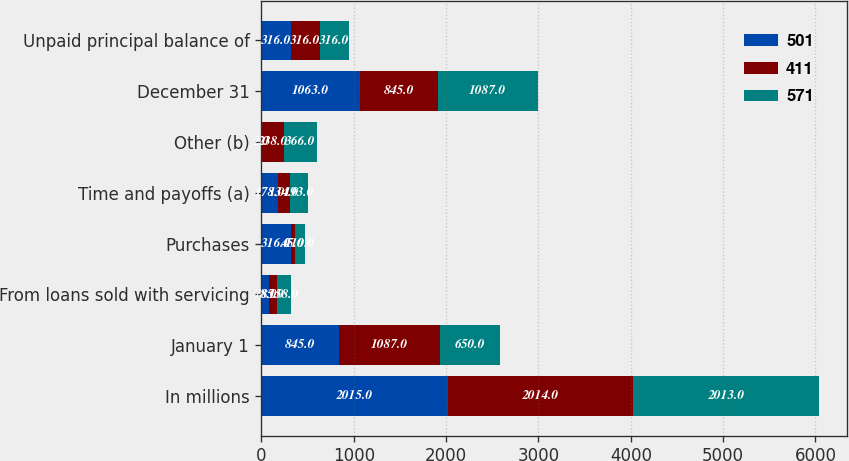<chart> <loc_0><loc_0><loc_500><loc_500><stacked_bar_chart><ecel><fcel>In millions<fcel>January 1<fcel>From loans sold with servicing<fcel>Purchases<fcel>Time and payoffs (a)<fcel>Other (b)<fcel>December 31<fcel>Unpaid principal balance of<nl><fcel>501<fcel>2015<fcel>845<fcel>78<fcel>316<fcel>178<fcel>2<fcel>1063<fcel>316<nl><fcel>411<fcel>2014<fcel>1087<fcel>85<fcel>45<fcel>134<fcel>238<fcel>845<fcel>316<nl><fcel>571<fcel>2013<fcel>650<fcel>158<fcel>110<fcel>193<fcel>366<fcel>1087<fcel>316<nl></chart> 